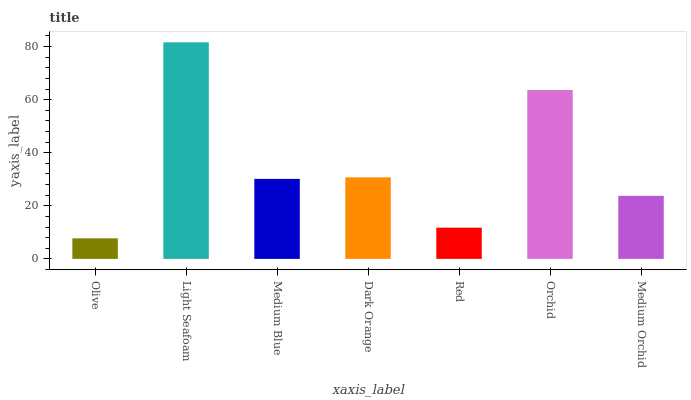Is Olive the minimum?
Answer yes or no. Yes. Is Light Seafoam the maximum?
Answer yes or no. Yes. Is Medium Blue the minimum?
Answer yes or no. No. Is Medium Blue the maximum?
Answer yes or no. No. Is Light Seafoam greater than Medium Blue?
Answer yes or no. Yes. Is Medium Blue less than Light Seafoam?
Answer yes or no. Yes. Is Medium Blue greater than Light Seafoam?
Answer yes or no. No. Is Light Seafoam less than Medium Blue?
Answer yes or no. No. Is Medium Blue the high median?
Answer yes or no. Yes. Is Medium Blue the low median?
Answer yes or no. Yes. Is Red the high median?
Answer yes or no. No. Is Red the low median?
Answer yes or no. No. 